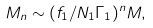Convert formula to latex. <formula><loc_0><loc_0><loc_500><loc_500>M _ { n } \sim ( f _ { 1 } / N _ { 1 } \Gamma _ { 1 } ) ^ { n } M ,</formula> 